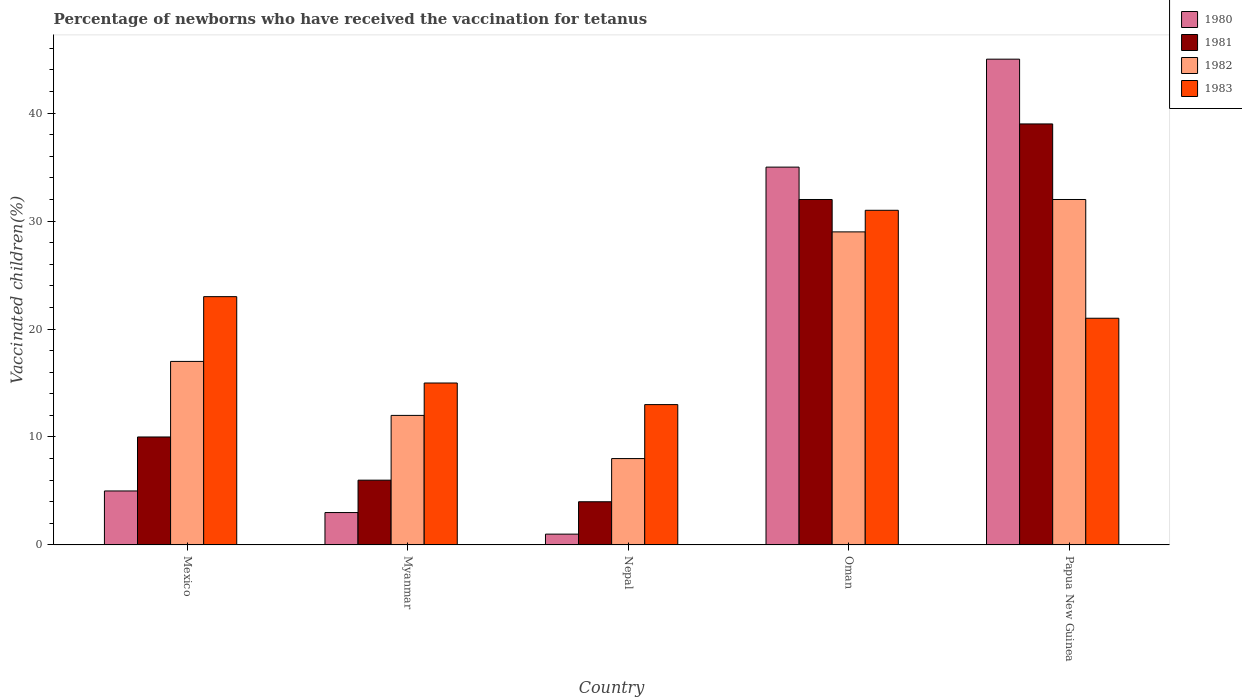How many groups of bars are there?
Make the answer very short. 5. Are the number of bars on each tick of the X-axis equal?
Keep it short and to the point. Yes. How many bars are there on the 4th tick from the left?
Offer a very short reply. 4. What is the label of the 3rd group of bars from the left?
Make the answer very short. Nepal. What is the percentage of vaccinated children in 1980 in Papua New Guinea?
Your answer should be compact. 45. Across all countries, what is the maximum percentage of vaccinated children in 1980?
Your response must be concise. 45. In which country was the percentage of vaccinated children in 1982 maximum?
Offer a very short reply. Papua New Guinea. In which country was the percentage of vaccinated children in 1980 minimum?
Keep it short and to the point. Nepal. What is the total percentage of vaccinated children in 1981 in the graph?
Ensure brevity in your answer.  91. What is the difference between the percentage of vaccinated children in 1980 in Mexico and that in Papua New Guinea?
Your response must be concise. -40. What is the average percentage of vaccinated children in 1983 per country?
Provide a succinct answer. 20.6. In how many countries, is the percentage of vaccinated children in 1980 greater than 6 %?
Your response must be concise. 2. What is the ratio of the percentage of vaccinated children in 1980 in Oman to that in Papua New Guinea?
Ensure brevity in your answer.  0.78. What is the difference between the highest and the lowest percentage of vaccinated children in 1980?
Make the answer very short. 44. Is it the case that in every country, the sum of the percentage of vaccinated children in 1982 and percentage of vaccinated children in 1981 is greater than the sum of percentage of vaccinated children in 1980 and percentage of vaccinated children in 1983?
Ensure brevity in your answer.  Yes. What does the 3rd bar from the right in Papua New Guinea represents?
Make the answer very short. 1981. How many bars are there?
Keep it short and to the point. 20. Are all the bars in the graph horizontal?
Your answer should be compact. No. How many countries are there in the graph?
Your response must be concise. 5. Does the graph contain any zero values?
Offer a very short reply. No. Does the graph contain grids?
Your response must be concise. No. Where does the legend appear in the graph?
Provide a short and direct response. Top right. What is the title of the graph?
Your answer should be compact. Percentage of newborns who have received the vaccination for tetanus. Does "1991" appear as one of the legend labels in the graph?
Keep it short and to the point. No. What is the label or title of the X-axis?
Your answer should be compact. Country. What is the label or title of the Y-axis?
Keep it short and to the point. Vaccinated children(%). What is the Vaccinated children(%) in 1981 in Mexico?
Ensure brevity in your answer.  10. What is the Vaccinated children(%) in 1982 in Mexico?
Make the answer very short. 17. What is the Vaccinated children(%) of 1983 in Mexico?
Your answer should be very brief. 23. What is the Vaccinated children(%) of 1980 in Myanmar?
Keep it short and to the point. 3. What is the Vaccinated children(%) of 1982 in Myanmar?
Make the answer very short. 12. What is the Vaccinated children(%) in 1982 in Nepal?
Your answer should be very brief. 8. What is the Vaccinated children(%) of 1983 in Nepal?
Offer a very short reply. 13. What is the Vaccinated children(%) of 1980 in Oman?
Offer a terse response. 35. What is the Vaccinated children(%) of 1981 in Oman?
Offer a very short reply. 32. What is the Vaccinated children(%) in 1982 in Oman?
Your answer should be very brief. 29. What is the Vaccinated children(%) in 1980 in Papua New Guinea?
Offer a terse response. 45. What is the Vaccinated children(%) in 1981 in Papua New Guinea?
Make the answer very short. 39. What is the Vaccinated children(%) in 1982 in Papua New Guinea?
Your answer should be compact. 32. Across all countries, what is the maximum Vaccinated children(%) of 1980?
Give a very brief answer. 45. Across all countries, what is the maximum Vaccinated children(%) of 1982?
Keep it short and to the point. 32. Across all countries, what is the minimum Vaccinated children(%) of 1982?
Provide a short and direct response. 8. Across all countries, what is the minimum Vaccinated children(%) in 1983?
Your answer should be very brief. 13. What is the total Vaccinated children(%) in 1980 in the graph?
Keep it short and to the point. 89. What is the total Vaccinated children(%) in 1981 in the graph?
Offer a very short reply. 91. What is the total Vaccinated children(%) in 1982 in the graph?
Provide a short and direct response. 98. What is the total Vaccinated children(%) of 1983 in the graph?
Offer a very short reply. 103. What is the difference between the Vaccinated children(%) in 1982 in Mexico and that in Myanmar?
Make the answer very short. 5. What is the difference between the Vaccinated children(%) in 1983 in Mexico and that in Myanmar?
Your answer should be compact. 8. What is the difference between the Vaccinated children(%) of 1980 in Mexico and that in Nepal?
Ensure brevity in your answer.  4. What is the difference between the Vaccinated children(%) of 1981 in Mexico and that in Nepal?
Provide a succinct answer. 6. What is the difference between the Vaccinated children(%) of 1981 in Mexico and that in Oman?
Provide a succinct answer. -22. What is the difference between the Vaccinated children(%) of 1982 in Mexico and that in Oman?
Your answer should be compact. -12. What is the difference between the Vaccinated children(%) of 1983 in Mexico and that in Oman?
Provide a short and direct response. -8. What is the difference between the Vaccinated children(%) in 1980 in Mexico and that in Papua New Guinea?
Offer a terse response. -40. What is the difference between the Vaccinated children(%) of 1981 in Mexico and that in Papua New Guinea?
Provide a succinct answer. -29. What is the difference between the Vaccinated children(%) in 1982 in Mexico and that in Papua New Guinea?
Offer a terse response. -15. What is the difference between the Vaccinated children(%) in 1983 in Mexico and that in Papua New Guinea?
Offer a very short reply. 2. What is the difference between the Vaccinated children(%) of 1981 in Myanmar and that in Nepal?
Make the answer very short. 2. What is the difference between the Vaccinated children(%) in 1982 in Myanmar and that in Nepal?
Give a very brief answer. 4. What is the difference between the Vaccinated children(%) of 1980 in Myanmar and that in Oman?
Offer a very short reply. -32. What is the difference between the Vaccinated children(%) of 1982 in Myanmar and that in Oman?
Your answer should be compact. -17. What is the difference between the Vaccinated children(%) in 1983 in Myanmar and that in Oman?
Give a very brief answer. -16. What is the difference between the Vaccinated children(%) in 1980 in Myanmar and that in Papua New Guinea?
Ensure brevity in your answer.  -42. What is the difference between the Vaccinated children(%) of 1981 in Myanmar and that in Papua New Guinea?
Make the answer very short. -33. What is the difference between the Vaccinated children(%) of 1982 in Myanmar and that in Papua New Guinea?
Give a very brief answer. -20. What is the difference between the Vaccinated children(%) in 1980 in Nepal and that in Oman?
Provide a succinct answer. -34. What is the difference between the Vaccinated children(%) in 1981 in Nepal and that in Oman?
Provide a succinct answer. -28. What is the difference between the Vaccinated children(%) in 1982 in Nepal and that in Oman?
Your answer should be compact. -21. What is the difference between the Vaccinated children(%) in 1983 in Nepal and that in Oman?
Your response must be concise. -18. What is the difference between the Vaccinated children(%) in 1980 in Nepal and that in Papua New Guinea?
Your answer should be very brief. -44. What is the difference between the Vaccinated children(%) in 1981 in Nepal and that in Papua New Guinea?
Provide a short and direct response. -35. What is the difference between the Vaccinated children(%) of 1982 in Nepal and that in Papua New Guinea?
Ensure brevity in your answer.  -24. What is the difference between the Vaccinated children(%) of 1980 in Oman and that in Papua New Guinea?
Make the answer very short. -10. What is the difference between the Vaccinated children(%) of 1980 in Mexico and the Vaccinated children(%) of 1981 in Myanmar?
Give a very brief answer. -1. What is the difference between the Vaccinated children(%) of 1980 in Mexico and the Vaccinated children(%) of 1981 in Nepal?
Give a very brief answer. 1. What is the difference between the Vaccinated children(%) in 1980 in Mexico and the Vaccinated children(%) in 1982 in Oman?
Give a very brief answer. -24. What is the difference between the Vaccinated children(%) in 1982 in Mexico and the Vaccinated children(%) in 1983 in Oman?
Offer a very short reply. -14. What is the difference between the Vaccinated children(%) in 1980 in Mexico and the Vaccinated children(%) in 1981 in Papua New Guinea?
Offer a very short reply. -34. What is the difference between the Vaccinated children(%) in 1980 in Mexico and the Vaccinated children(%) in 1983 in Papua New Guinea?
Make the answer very short. -16. What is the difference between the Vaccinated children(%) of 1981 in Mexico and the Vaccinated children(%) of 1982 in Papua New Guinea?
Make the answer very short. -22. What is the difference between the Vaccinated children(%) in 1981 in Mexico and the Vaccinated children(%) in 1983 in Papua New Guinea?
Your response must be concise. -11. What is the difference between the Vaccinated children(%) of 1980 in Myanmar and the Vaccinated children(%) of 1981 in Nepal?
Your answer should be compact. -1. What is the difference between the Vaccinated children(%) of 1980 in Myanmar and the Vaccinated children(%) of 1983 in Nepal?
Keep it short and to the point. -10. What is the difference between the Vaccinated children(%) of 1980 in Myanmar and the Vaccinated children(%) of 1982 in Oman?
Offer a terse response. -26. What is the difference between the Vaccinated children(%) of 1981 in Myanmar and the Vaccinated children(%) of 1982 in Oman?
Provide a short and direct response. -23. What is the difference between the Vaccinated children(%) in 1982 in Myanmar and the Vaccinated children(%) in 1983 in Oman?
Provide a succinct answer. -19. What is the difference between the Vaccinated children(%) of 1980 in Myanmar and the Vaccinated children(%) of 1981 in Papua New Guinea?
Your response must be concise. -36. What is the difference between the Vaccinated children(%) in 1982 in Myanmar and the Vaccinated children(%) in 1983 in Papua New Guinea?
Ensure brevity in your answer.  -9. What is the difference between the Vaccinated children(%) in 1980 in Nepal and the Vaccinated children(%) in 1981 in Oman?
Make the answer very short. -31. What is the difference between the Vaccinated children(%) of 1980 in Nepal and the Vaccinated children(%) of 1983 in Oman?
Provide a succinct answer. -30. What is the difference between the Vaccinated children(%) in 1981 in Nepal and the Vaccinated children(%) in 1982 in Oman?
Offer a very short reply. -25. What is the difference between the Vaccinated children(%) in 1981 in Nepal and the Vaccinated children(%) in 1983 in Oman?
Provide a succinct answer. -27. What is the difference between the Vaccinated children(%) in 1982 in Nepal and the Vaccinated children(%) in 1983 in Oman?
Your response must be concise. -23. What is the difference between the Vaccinated children(%) in 1980 in Nepal and the Vaccinated children(%) in 1981 in Papua New Guinea?
Your response must be concise. -38. What is the difference between the Vaccinated children(%) of 1980 in Nepal and the Vaccinated children(%) of 1982 in Papua New Guinea?
Provide a short and direct response. -31. What is the difference between the Vaccinated children(%) in 1980 in Nepal and the Vaccinated children(%) in 1983 in Papua New Guinea?
Provide a succinct answer. -20. What is the difference between the Vaccinated children(%) in 1980 in Oman and the Vaccinated children(%) in 1982 in Papua New Guinea?
Give a very brief answer. 3. What is the difference between the Vaccinated children(%) in 1980 in Oman and the Vaccinated children(%) in 1983 in Papua New Guinea?
Offer a very short reply. 14. What is the difference between the Vaccinated children(%) in 1981 in Oman and the Vaccinated children(%) in 1982 in Papua New Guinea?
Provide a short and direct response. 0. What is the difference between the Vaccinated children(%) in 1981 in Oman and the Vaccinated children(%) in 1983 in Papua New Guinea?
Give a very brief answer. 11. What is the difference between the Vaccinated children(%) in 1982 in Oman and the Vaccinated children(%) in 1983 in Papua New Guinea?
Keep it short and to the point. 8. What is the average Vaccinated children(%) of 1980 per country?
Ensure brevity in your answer.  17.8. What is the average Vaccinated children(%) of 1981 per country?
Offer a very short reply. 18.2. What is the average Vaccinated children(%) in 1982 per country?
Your response must be concise. 19.6. What is the average Vaccinated children(%) of 1983 per country?
Offer a terse response. 20.6. What is the difference between the Vaccinated children(%) of 1980 and Vaccinated children(%) of 1982 in Mexico?
Provide a succinct answer. -12. What is the difference between the Vaccinated children(%) of 1980 and Vaccinated children(%) of 1983 in Mexico?
Ensure brevity in your answer.  -18. What is the difference between the Vaccinated children(%) in 1981 and Vaccinated children(%) in 1982 in Mexico?
Give a very brief answer. -7. What is the difference between the Vaccinated children(%) in 1981 and Vaccinated children(%) in 1983 in Mexico?
Your answer should be compact. -13. What is the difference between the Vaccinated children(%) of 1980 and Vaccinated children(%) of 1982 in Myanmar?
Ensure brevity in your answer.  -9. What is the difference between the Vaccinated children(%) of 1980 and Vaccinated children(%) of 1983 in Myanmar?
Offer a very short reply. -12. What is the difference between the Vaccinated children(%) in 1980 and Vaccinated children(%) in 1981 in Nepal?
Make the answer very short. -3. What is the difference between the Vaccinated children(%) of 1980 and Vaccinated children(%) of 1982 in Nepal?
Your answer should be compact. -7. What is the difference between the Vaccinated children(%) in 1981 and Vaccinated children(%) in 1982 in Nepal?
Give a very brief answer. -4. What is the difference between the Vaccinated children(%) of 1981 and Vaccinated children(%) of 1983 in Nepal?
Provide a short and direct response. -9. What is the difference between the Vaccinated children(%) in 1982 and Vaccinated children(%) in 1983 in Nepal?
Make the answer very short. -5. What is the difference between the Vaccinated children(%) of 1980 and Vaccinated children(%) of 1981 in Oman?
Keep it short and to the point. 3. What is the difference between the Vaccinated children(%) in 1980 and Vaccinated children(%) in 1982 in Oman?
Your response must be concise. 6. What is the difference between the Vaccinated children(%) of 1980 and Vaccinated children(%) of 1983 in Oman?
Your answer should be very brief. 4. What is the difference between the Vaccinated children(%) in 1981 and Vaccinated children(%) in 1983 in Oman?
Provide a succinct answer. 1. What is the difference between the Vaccinated children(%) of 1982 and Vaccinated children(%) of 1983 in Oman?
Keep it short and to the point. -2. What is the difference between the Vaccinated children(%) in 1980 and Vaccinated children(%) in 1982 in Papua New Guinea?
Keep it short and to the point. 13. What is the difference between the Vaccinated children(%) in 1981 and Vaccinated children(%) in 1982 in Papua New Guinea?
Provide a short and direct response. 7. What is the difference between the Vaccinated children(%) of 1981 and Vaccinated children(%) of 1983 in Papua New Guinea?
Ensure brevity in your answer.  18. What is the ratio of the Vaccinated children(%) of 1980 in Mexico to that in Myanmar?
Your answer should be very brief. 1.67. What is the ratio of the Vaccinated children(%) in 1981 in Mexico to that in Myanmar?
Ensure brevity in your answer.  1.67. What is the ratio of the Vaccinated children(%) in 1982 in Mexico to that in Myanmar?
Provide a short and direct response. 1.42. What is the ratio of the Vaccinated children(%) of 1983 in Mexico to that in Myanmar?
Give a very brief answer. 1.53. What is the ratio of the Vaccinated children(%) in 1980 in Mexico to that in Nepal?
Provide a succinct answer. 5. What is the ratio of the Vaccinated children(%) in 1981 in Mexico to that in Nepal?
Make the answer very short. 2.5. What is the ratio of the Vaccinated children(%) in 1982 in Mexico to that in Nepal?
Keep it short and to the point. 2.12. What is the ratio of the Vaccinated children(%) of 1983 in Mexico to that in Nepal?
Offer a terse response. 1.77. What is the ratio of the Vaccinated children(%) of 1980 in Mexico to that in Oman?
Provide a succinct answer. 0.14. What is the ratio of the Vaccinated children(%) of 1981 in Mexico to that in Oman?
Your answer should be compact. 0.31. What is the ratio of the Vaccinated children(%) in 1982 in Mexico to that in Oman?
Make the answer very short. 0.59. What is the ratio of the Vaccinated children(%) of 1983 in Mexico to that in Oman?
Offer a terse response. 0.74. What is the ratio of the Vaccinated children(%) of 1980 in Mexico to that in Papua New Guinea?
Offer a terse response. 0.11. What is the ratio of the Vaccinated children(%) of 1981 in Mexico to that in Papua New Guinea?
Provide a succinct answer. 0.26. What is the ratio of the Vaccinated children(%) in 1982 in Mexico to that in Papua New Guinea?
Keep it short and to the point. 0.53. What is the ratio of the Vaccinated children(%) of 1983 in Mexico to that in Papua New Guinea?
Your response must be concise. 1.1. What is the ratio of the Vaccinated children(%) in 1980 in Myanmar to that in Nepal?
Ensure brevity in your answer.  3. What is the ratio of the Vaccinated children(%) in 1981 in Myanmar to that in Nepal?
Offer a terse response. 1.5. What is the ratio of the Vaccinated children(%) of 1983 in Myanmar to that in Nepal?
Your answer should be very brief. 1.15. What is the ratio of the Vaccinated children(%) of 1980 in Myanmar to that in Oman?
Provide a short and direct response. 0.09. What is the ratio of the Vaccinated children(%) in 1981 in Myanmar to that in Oman?
Your response must be concise. 0.19. What is the ratio of the Vaccinated children(%) of 1982 in Myanmar to that in Oman?
Offer a terse response. 0.41. What is the ratio of the Vaccinated children(%) of 1983 in Myanmar to that in Oman?
Offer a very short reply. 0.48. What is the ratio of the Vaccinated children(%) of 1980 in Myanmar to that in Papua New Guinea?
Make the answer very short. 0.07. What is the ratio of the Vaccinated children(%) in 1981 in Myanmar to that in Papua New Guinea?
Keep it short and to the point. 0.15. What is the ratio of the Vaccinated children(%) in 1982 in Myanmar to that in Papua New Guinea?
Make the answer very short. 0.38. What is the ratio of the Vaccinated children(%) in 1983 in Myanmar to that in Papua New Guinea?
Provide a short and direct response. 0.71. What is the ratio of the Vaccinated children(%) in 1980 in Nepal to that in Oman?
Your answer should be compact. 0.03. What is the ratio of the Vaccinated children(%) in 1981 in Nepal to that in Oman?
Provide a short and direct response. 0.12. What is the ratio of the Vaccinated children(%) in 1982 in Nepal to that in Oman?
Offer a very short reply. 0.28. What is the ratio of the Vaccinated children(%) in 1983 in Nepal to that in Oman?
Make the answer very short. 0.42. What is the ratio of the Vaccinated children(%) of 1980 in Nepal to that in Papua New Guinea?
Make the answer very short. 0.02. What is the ratio of the Vaccinated children(%) of 1981 in Nepal to that in Papua New Guinea?
Provide a succinct answer. 0.1. What is the ratio of the Vaccinated children(%) of 1983 in Nepal to that in Papua New Guinea?
Ensure brevity in your answer.  0.62. What is the ratio of the Vaccinated children(%) of 1981 in Oman to that in Papua New Guinea?
Provide a succinct answer. 0.82. What is the ratio of the Vaccinated children(%) of 1982 in Oman to that in Papua New Guinea?
Offer a very short reply. 0.91. What is the ratio of the Vaccinated children(%) in 1983 in Oman to that in Papua New Guinea?
Provide a succinct answer. 1.48. What is the difference between the highest and the second highest Vaccinated children(%) of 1980?
Keep it short and to the point. 10. What is the difference between the highest and the second highest Vaccinated children(%) of 1981?
Offer a very short reply. 7. What is the difference between the highest and the second highest Vaccinated children(%) of 1983?
Keep it short and to the point. 8. What is the difference between the highest and the lowest Vaccinated children(%) of 1981?
Offer a very short reply. 35. What is the difference between the highest and the lowest Vaccinated children(%) in 1982?
Your answer should be compact. 24. 